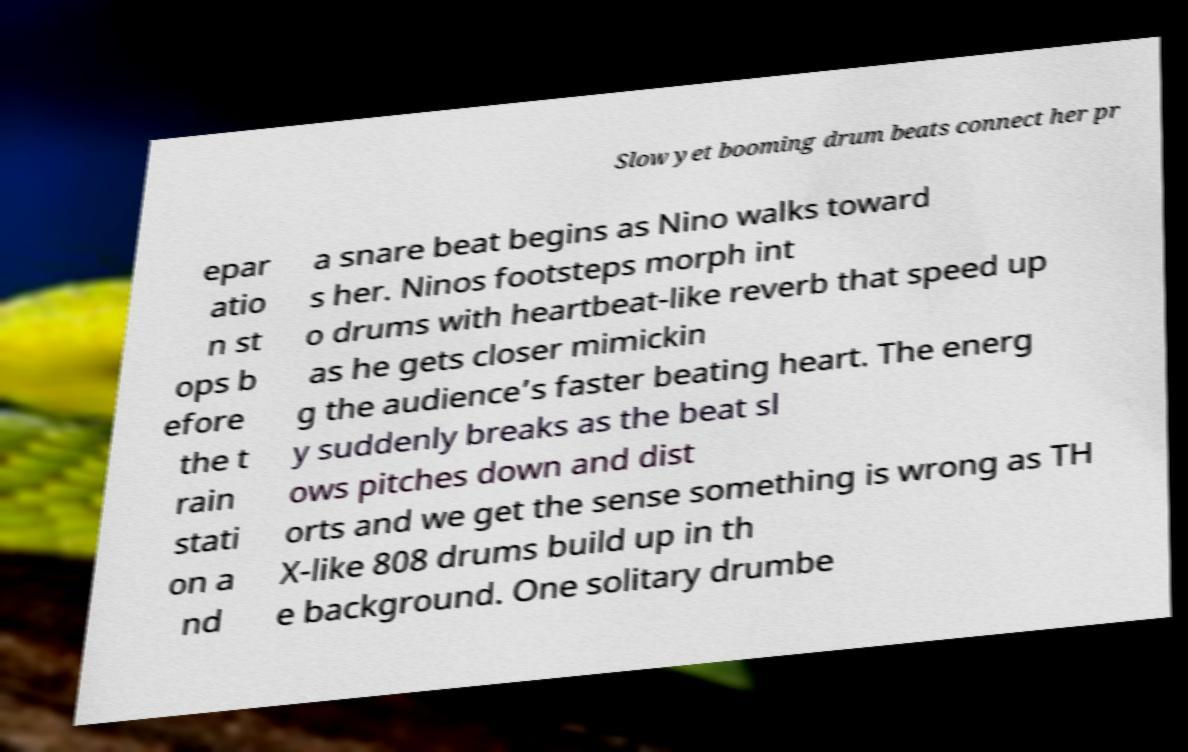What messages or text are displayed in this image? I need them in a readable, typed format. Slow yet booming drum beats connect her pr epar atio n st ops b efore the t rain stati on a nd a snare beat begins as Nino walks toward s her. Ninos footsteps morph int o drums with heartbeat-like reverb that speed up as he gets closer mimickin g the audience’s faster beating heart. The energ y suddenly breaks as the beat sl ows pitches down and dist orts and we get the sense something is wrong as TH X-like 808 drums build up in th e background. One solitary drumbe 